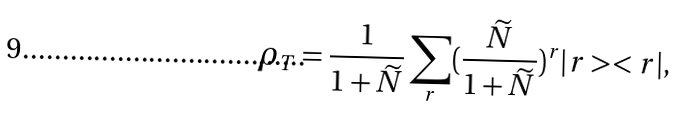<formula> <loc_0><loc_0><loc_500><loc_500>\rho _ { T } = \frac { 1 } { 1 + \widetilde { N } } \sum _ { r } ( \frac { \widetilde { N } } { 1 + \widetilde { N } } ) ^ { r } | r > < r | ,</formula> 